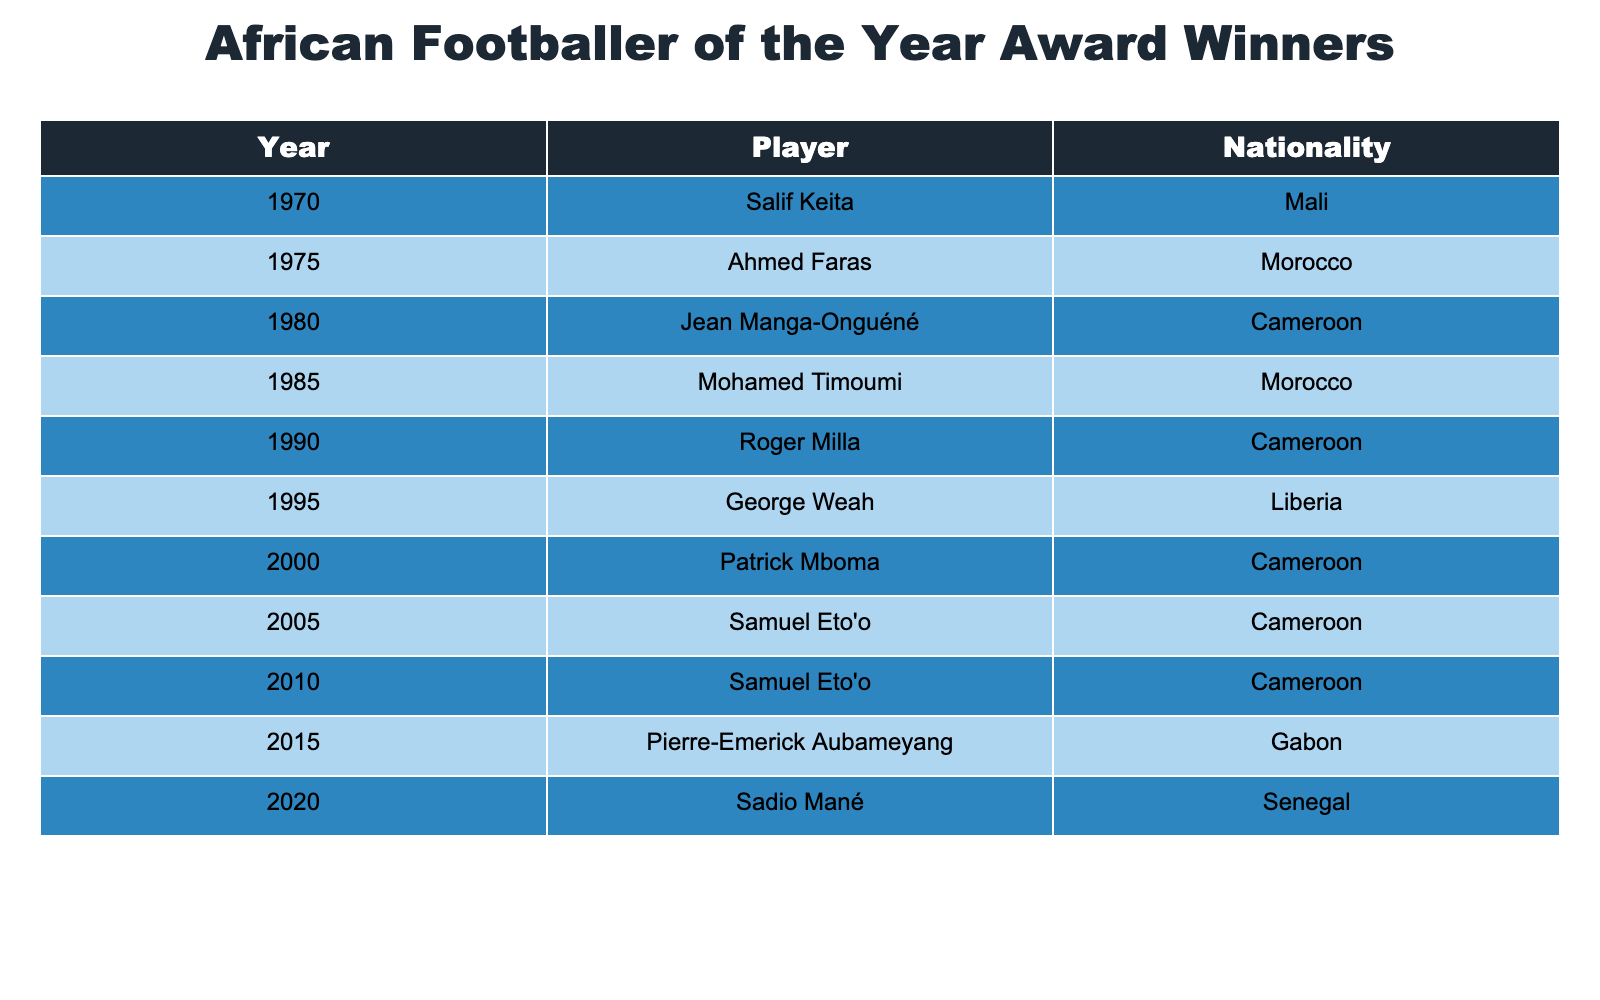What's the nationality of the player who won the award in 1995? Looking at the table, the player who won the award in 1995 is George Weah, and his nationality is Liberia.
Answer: Liberia How many times did Samuel Eto'o win the African Footballer of the Year award? The table shows that Samuel Eto'o is listed as the winner in the years 2005 and 2010, indicating he won the award twice.
Answer: Twice Which country had the most winners listed in the table? By counting the occurrences in the nationality column, Cameroon has the most winners (4 times: 1980, 1990, 2000, 2005, and 2010).
Answer: Cameroon Was there any player from Gabon who won the award? The table lists Pierre-Emerick Aubameyang as the winner in 2015, and he is from Gabon, confirming that there is a player from Gabon.
Answer: Yes List the years in which players from Morocco won the award. Looking closely, the table shows that players from Morocco won in 1975 and 1985.
Answer: 1975, 1985 How many different nationalities are represented among the winners? By examining the nationality column, we find the unique nationalities: Mali, Morocco, Cameroon, Liberia, Gabon, Senegal. There are a total of 6 different nationalities.
Answer: 6 Who won the award the latest from the table? The latest year listed in the table is 2020, and the player who won the award that year is Sadio Mané from Senegal.
Answer: Sadio Mané Compare the total number of wins by Cameroonian players to the total wins by players from other countries. Cameroonian players won 4 times (1980, 1990, 2000, 2005, 2010). The total number of wins by players from other countries combined is 6 (Mali - 1, Morocco - 2, Liberia - 1, Gabon - 1, Senegal - 1).
Answer: Cameroonian players won 4 times; others won 6 times What is the average number of awards won by each nationality represented in the table? First, we count the wins by nationality: Cameroon (4), Morocco (2), Liberia (1), Mali (1), Gabon (1), Senegal (1). Adding these gives us 10 total awards. Dividing 10 (total) by 6 (nationalities) gives us an average of approximately 1.67 awards per nationality.
Answer: Approximately 1.67 